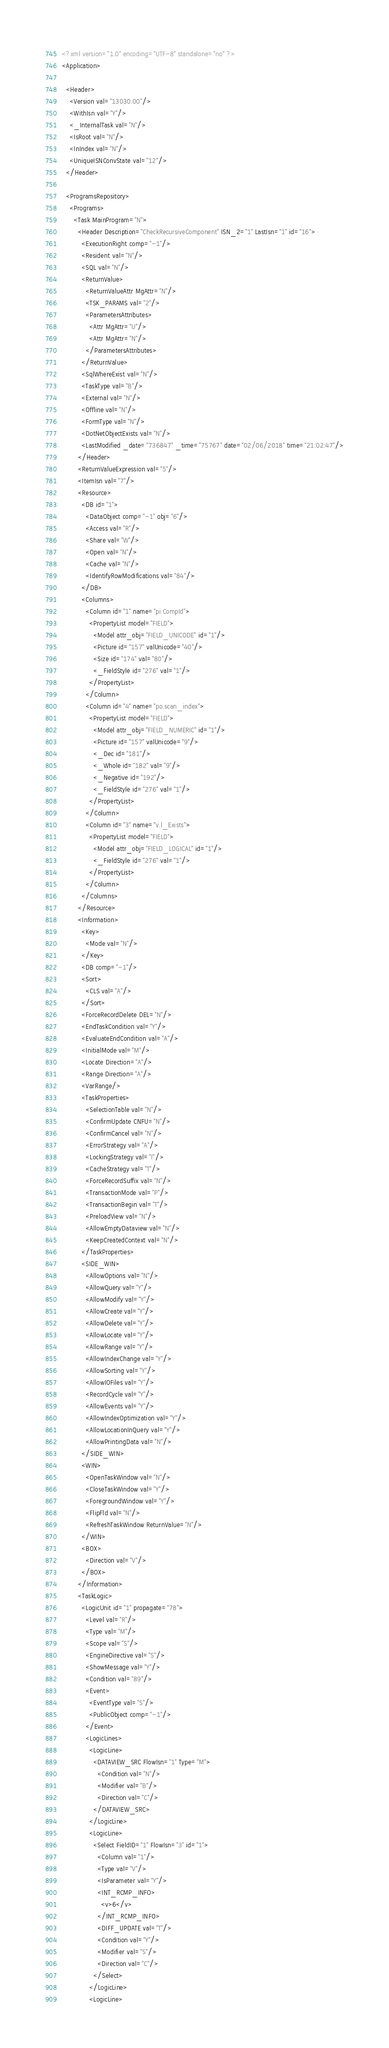<code> <loc_0><loc_0><loc_500><loc_500><_XML_><?xml version="1.0" encoding="UTF-8" standalone="no" ?>
<Application>

  <Header>
    <Version val="13030.00"/>
    <WithIsn val="Y"/>
    <_InternalTask val="N"/>
    <IsRoot val="N"/>
    <InIndex val="N"/>
    <UniqueISNConvState val="12"/>
  </Header>

  <ProgramsRepository>
    <Programs>
      <Task MainProgram="N">
        <Header Description="CheckRecursiveComponent" ISN_2="1" LastIsn="1" id="16">
          <ExecutionRight comp="-1"/>
          <Resident val="N"/>
          <SQL val="N"/>
          <ReturnValue>
            <ReturnValueAttr MgAttr="N"/>
            <TSK_PARAMS val="2"/>
            <ParametersAttributes>
              <Attr MgAttr="U"/>
              <Attr MgAttr="N"/>
            </ParametersAttributes>
          </ReturnValue>
          <SqlWhereExist val="N"/>
          <TaskType val="B"/>
          <External val="N"/>
          <Offline val="N"/>
          <FormType val="N"/>
          <DotNetObjectExists val="N"/>
          <LastModified _date="736847" _time="75767" date="02/06/2018" time="21:02:47"/>
        </Header>
        <ReturnValueExpression val="5"/>
        <ItemIsn val="7"/>
        <Resource>
          <DB id="1">
            <DataObject comp="-1" obj="6"/>
            <Access val="R"/>
            <Share val="W"/>
            <Open val="N"/>
            <Cache val="N"/>
            <IdentifyRowModifications val="84"/>
          </DB>
          <Columns>
            <Column id="1" name="pi.CompId">
              <PropertyList model="FIELD">
                <Model attr_obj="FIELD_UNICODE" id="1"/>
                <Picture id="157" valUnicode="40"/>
                <Size id="174" val="80"/>
                <_FieldStyle id="276" val="1"/>
              </PropertyList>
            </Column>
            <Column id="4" name="po.scan_index">
              <PropertyList model="FIELD">
                <Model attr_obj="FIELD_NUMERIC" id="1"/>
                <Picture id="157" valUnicode="9"/>
                <_Dec id="181"/>
                <_Whole id="182" val="9"/>
                <_Negative id="192"/>
                <_FieldStyle id="276" val="1"/>
              </PropertyList>
            </Column>
            <Column id="3" name="v.l_Exists">
              <PropertyList model="FIELD">
                <Model attr_obj="FIELD_LOGICAL" id="1"/>
                <_FieldStyle id="276" val="1"/>
              </PropertyList>
            </Column>
          </Columns>
        </Resource>
        <Information>
          <Key>
            <Mode val="N"/>
          </Key>
          <DB comp="-1"/>
          <Sort>
            <CLS val="A"/>
          </Sort>
          <ForceRecordDelete DEL="N"/>
          <EndTaskCondition val="Y"/>
          <EvaluateEndCondition val="A"/>
          <InitialMode val="M"/>
          <Locate Direction="A"/>
          <Range Direction="A"/>
          <VarRange/>
          <TaskProperties>
            <SelectionTable val="N"/>
            <ConfirmUpdate CNFU="N"/>
            <ConfirmCancel val="N"/>
            <ErrorStrategy val="A"/>
            <LockingStrategy val="I"/>
            <CacheStrategy val="T"/>
            <ForceRecordSuffix val="N"/>
            <TransactionMode val="P"/>
            <TransactionBegin val="T"/>
            <PreloadView val="N"/>
            <AllowEmptyDataview val="N"/>
            <KeepCreatedContext val="N"/>
          </TaskProperties>
          <SIDE_WIN>
            <AllowOptions val="N"/>
            <AllowQuery val="Y"/>
            <AllowModify val="Y"/>
            <AllowCreate val="Y"/>
            <AllowDelete val="Y"/>
            <AllowLocate val="Y"/>
            <AllowRange val="Y"/>
            <AllowIndexChange val="Y"/>
            <AllowSorting val="Y"/>
            <AllowIOFiles val="Y"/>
            <RecordCycle val="Y"/>
            <AllowEvents val="Y"/>
            <AllowIndexOptimization val="Y"/>
            <AllowLocationInQuery val="Y"/>
            <AllowPrintingData val="N"/>
          </SIDE_WIN>
          <WIN>
            <OpenTaskWindow val="N"/>
            <CloseTaskWindow val="Y"/>
            <ForegroundWindow val="Y"/>
            <FlipFld val="N"/>
            <RefreshTaskWindow ReturnValue="N"/>
          </WIN>
          <BOX>
            <Direction val="V"/>
          </BOX>
        </Information>
        <TaskLogic>
          <LogicUnit id="1" propagate="78">
            <Level val="R"/>
            <Type val="M"/>
            <Scope val="S"/>
            <EngineDirective val="S"/>
            <ShowMessage val="Y"/>
            <Condition val="89"/>
            <Event>
              <EventType val="S"/>
              <PublicObject comp="-1"/>
            </Event>
            <LogicLines>
              <LogicLine>
                <DATAVIEW_SRC FlowIsn="1" Type="M">
                  <Condition val="N"/>
                  <Modifier val="B"/>
                  <Direction val="C"/>
                </DATAVIEW_SRC>
              </LogicLine>
              <LogicLine>
                <Select FieldID="1" FlowIsn="3" id="1">
                  <Column val="1"/>
                  <Type val="V"/>
                  <IsParameter val="Y"/>
                  <INT_RCMP_INFO>
                    <v>6</v>
                  </INT_RCMP_INFO>
                  <DIFF_UPDATE val="T"/>
                  <Condition val="Y"/>
                  <Modifier val="S"/>
                  <Direction val="C"/>
                </Select>
              </LogicLine>
              <LogicLine></code> 